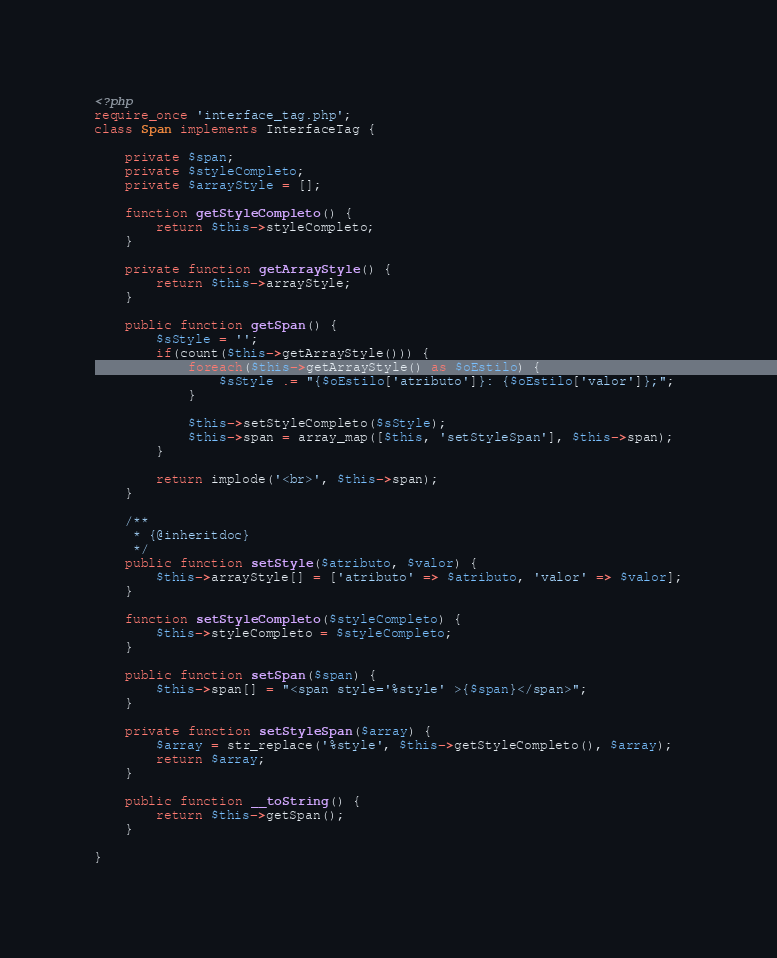Convert code to text. <code><loc_0><loc_0><loc_500><loc_500><_PHP_><?php
require_once 'interface_tag.php';
class Span implements InterfaceTag {
    
    private $span;
    private $styleCompleto;
    private $arrayStyle = [];
    
    function getStyleCompleto() {
        return $this->styleCompleto;
    }
    
    private function getArrayStyle() {
        return $this->arrayStyle;
    }
    
    public function getSpan() {
        $sStyle = '';
        if(count($this->getArrayStyle())) {
            foreach($this->getArrayStyle() as $oEstilo) {
                $sStyle .= "{$oEstilo['atributo']}: {$oEstilo['valor']};";
            }
            
            $this->setStyleCompleto($sStyle);
            $this->span = array_map([$this, 'setStyleSpan'], $this->span);
        }
        
        return implode('<br>', $this->span);
    }
    
    /**
     * {@inheritdoc}
     */
    public function setStyle($atributo, $valor) {
        $this->arrayStyle[] = ['atributo' => $atributo, 'valor' => $valor];
    }

    function setStyleCompleto($styleCompleto) {
        $this->styleCompleto = $styleCompleto;
    }
    
    public function setSpan($span) {
        $this->span[] = "<span style='%style' >{$span}</span>";
    }
    
    private function setStyleSpan($array) {
        $array = str_replace('%style', $this->getStyleCompleto(), $array);
        return $array;
    }

    public function __toString() {
        return $this->getSpan();
    }
    
}</code> 